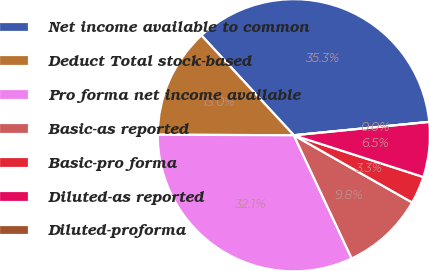Convert chart to OTSL. <chart><loc_0><loc_0><loc_500><loc_500><pie_chart><fcel>Net income available to common<fcel>Deduct Total stock-based<fcel>Pro forma net income available<fcel>Basic-as reported<fcel>Basic-pro forma<fcel>Diluted-as reported<fcel>Diluted-proforma<nl><fcel>35.32%<fcel>13.05%<fcel>32.06%<fcel>9.79%<fcel>3.26%<fcel>6.53%<fcel>0.0%<nl></chart> 